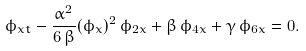Convert formula to latex. <formula><loc_0><loc_0><loc_500><loc_500>\phi _ { x t } - \frac { \alpha ^ { 2 } } { 6 \, \beta } ( \phi _ { x } ) ^ { 2 } \, \phi _ { 2 x } + \beta \, \phi _ { 4 x } + \gamma \, \phi _ { 6 x } = 0 .</formula> 